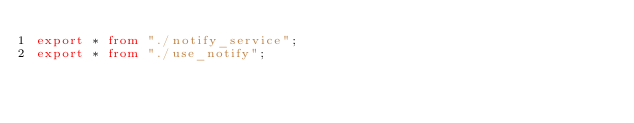Convert code to text. <code><loc_0><loc_0><loc_500><loc_500><_TypeScript_>export * from "./notify_service";
export * from "./use_notify";
</code> 